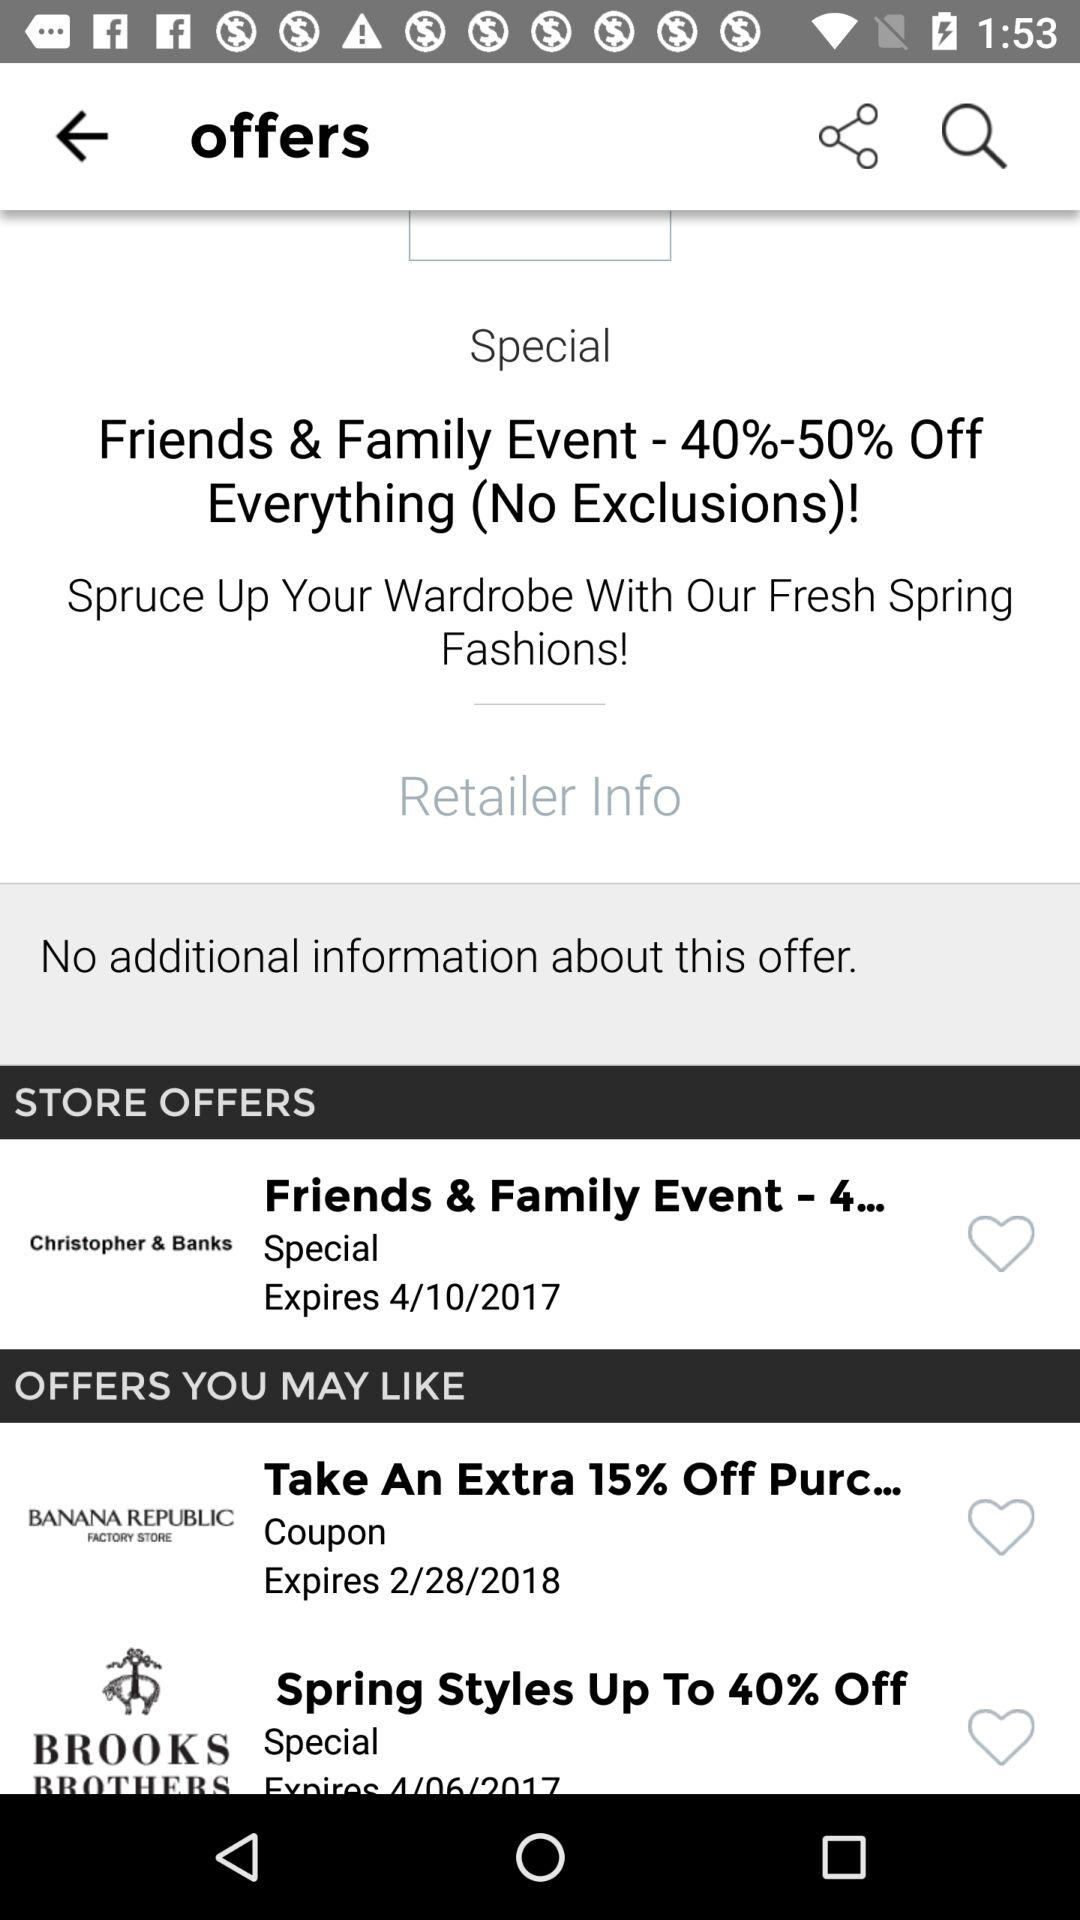Which company's coupon gives an extra 15% off? The company is "BANANA REPUBLIC FACTORY STORE". 